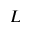Convert formula to latex. <formula><loc_0><loc_0><loc_500><loc_500>L</formula> 